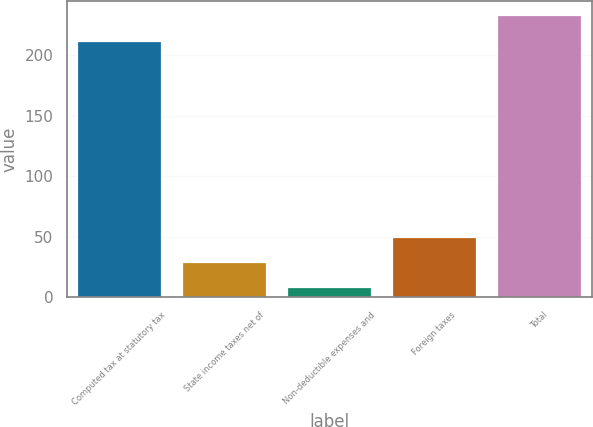<chart> <loc_0><loc_0><loc_500><loc_500><bar_chart><fcel>Computed tax at statutory tax<fcel>State income taxes net of<fcel>Non-deductible expenses and<fcel>Foreign taxes<fcel>Total<nl><fcel>212<fcel>29<fcel>8<fcel>50<fcel>233<nl></chart> 